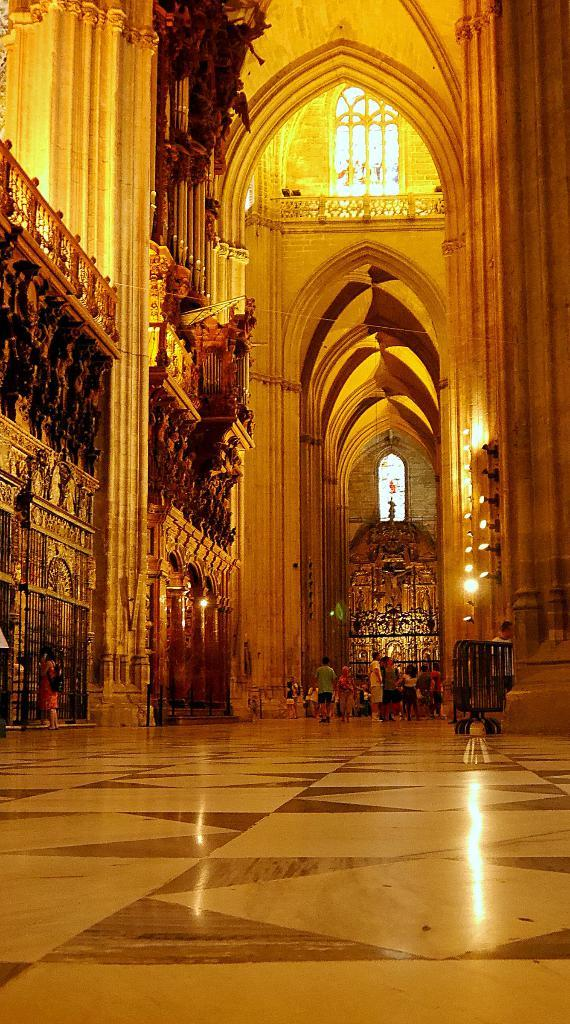What type of location is depicted in the image? The image shows an inside view of a building. Can you describe the people in the image? There are people in the image, but their specific actions or appearances are not mentioned in the provided facts. What part of the building can be seen in the image? The floor is visible in the image. What is present in the background of the image? There is a wall in the background of the image. What is providing illumination in the image? There are lights visible in the image. What type of loaf is being baked in the oven in the image? There is no oven or loaf present in the image. What territory is being claimed by the people in the image? There is no indication of any territory being claimed in the image. 